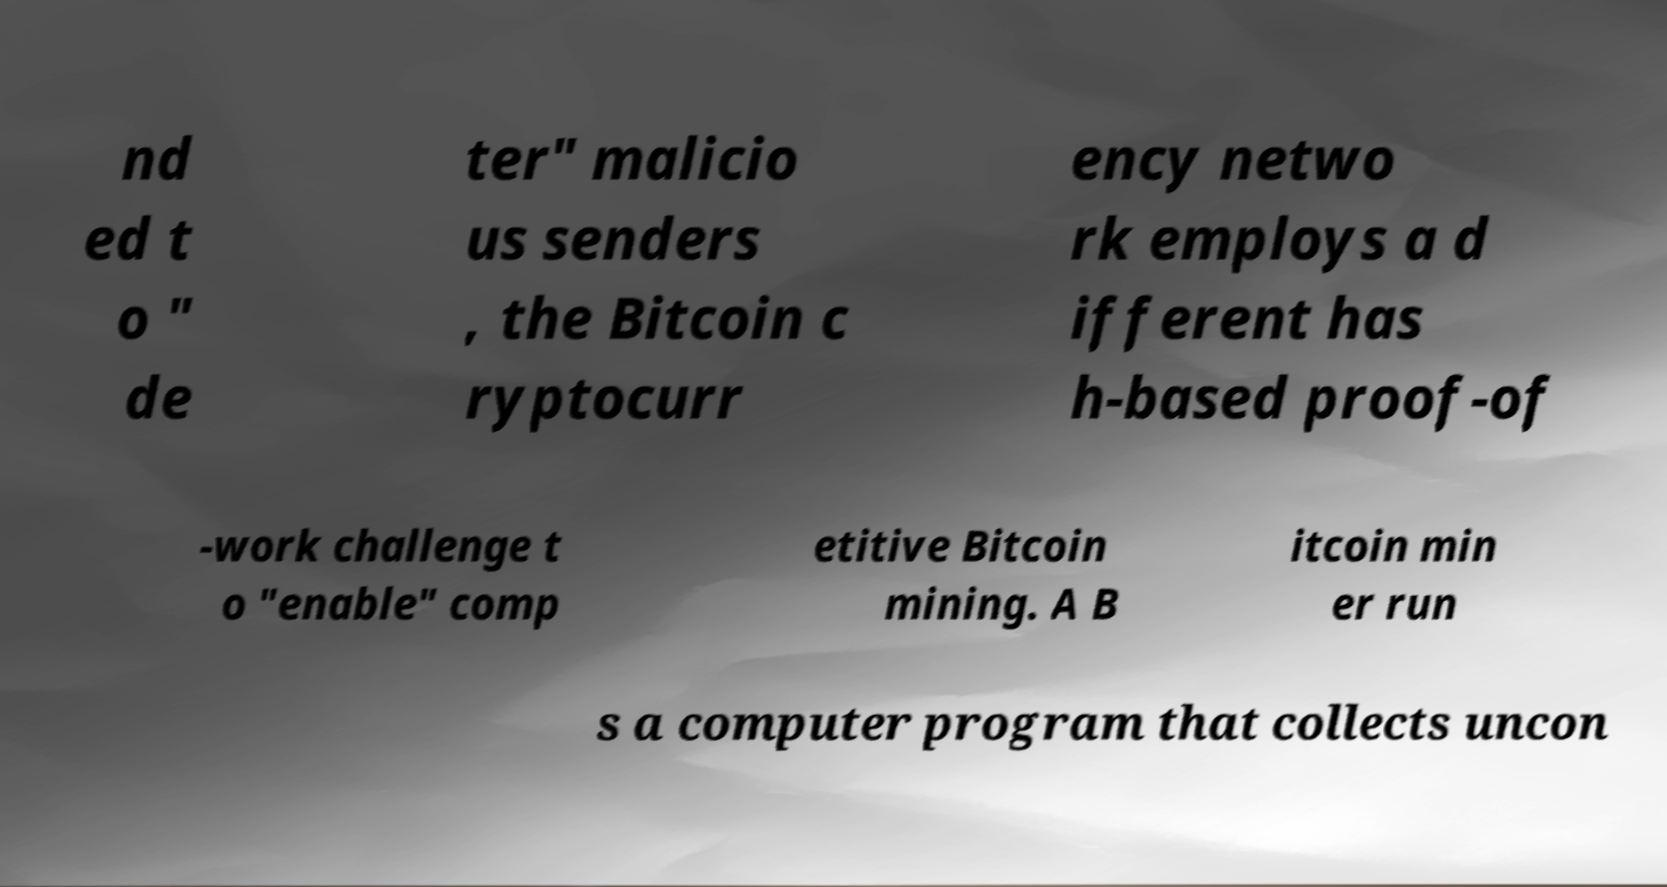Please read and relay the text visible in this image. What does it say? nd ed t o " de ter" malicio us senders , the Bitcoin c ryptocurr ency netwo rk employs a d ifferent has h-based proof-of -work challenge t o "enable" comp etitive Bitcoin mining. A B itcoin min er run s a computer program that collects uncon 